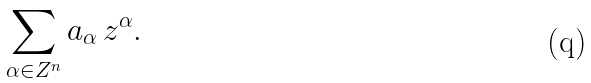Convert formula to latex. <formula><loc_0><loc_0><loc_500><loc_500>\sum _ { \alpha \in { Z } ^ { n } } a _ { \alpha } \, z ^ { \alpha } .</formula> 